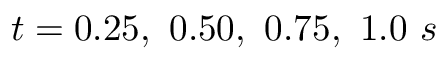<formula> <loc_0><loc_0><loc_500><loc_500>t = 0 . 2 5 , \ 0 . 5 0 , \ 0 . 7 5 , \ 1 . 0 \ s</formula> 